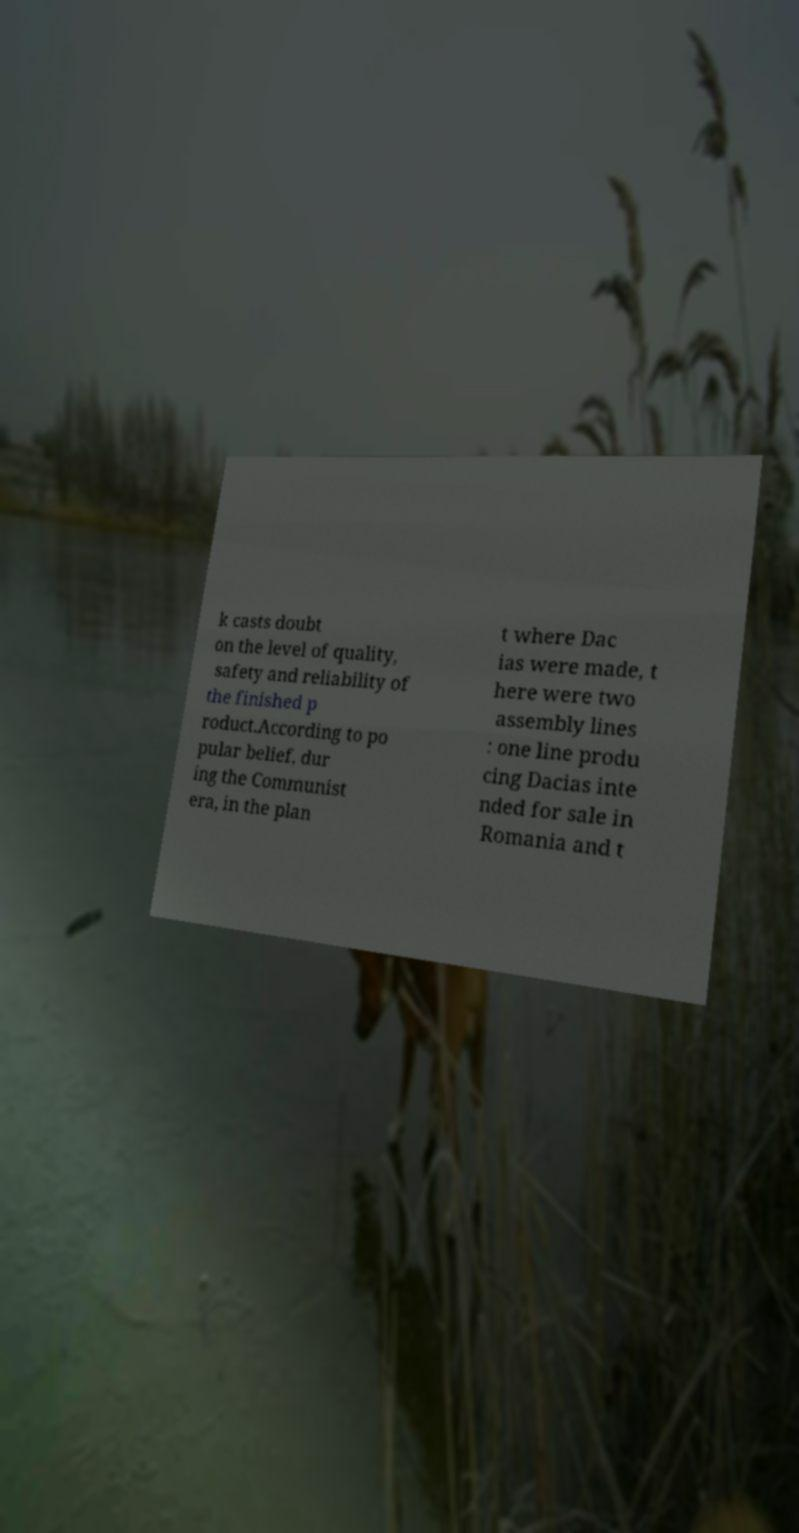Could you extract and type out the text from this image? k casts doubt on the level of quality, safety and reliability of the finished p roduct.According to po pular belief, dur ing the Communist era, in the plan t where Dac ias were made, t here were two assembly lines : one line produ cing Dacias inte nded for sale in Romania and t 